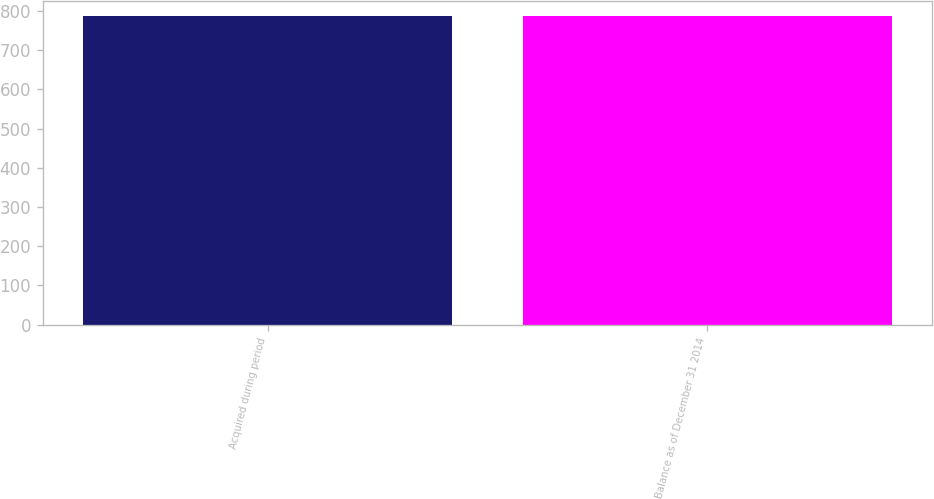<chart> <loc_0><loc_0><loc_500><loc_500><bar_chart><fcel>Acquired during period<fcel>Balance as of December 31 2014<nl><fcel>787<fcel>787.1<nl></chart> 